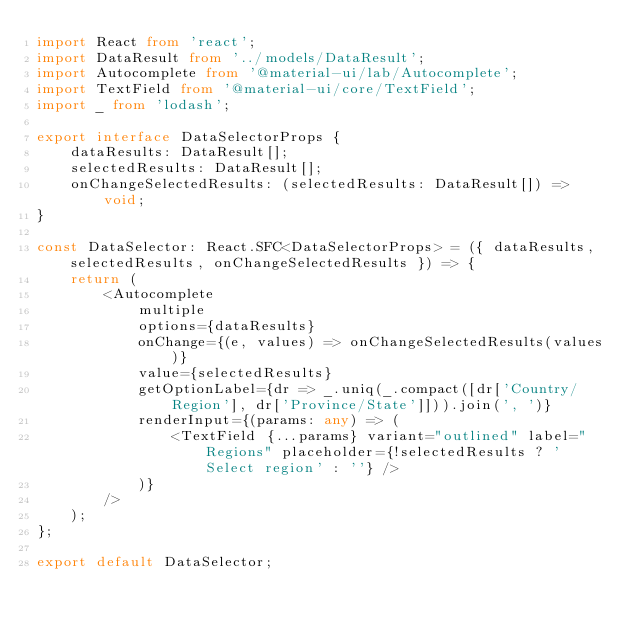Convert code to text. <code><loc_0><loc_0><loc_500><loc_500><_TypeScript_>import React from 'react';
import DataResult from '../models/DataResult';
import Autocomplete from '@material-ui/lab/Autocomplete';
import TextField from '@material-ui/core/TextField';
import _ from 'lodash';

export interface DataSelectorProps {
    dataResults: DataResult[];
    selectedResults: DataResult[];
    onChangeSelectedResults: (selectedResults: DataResult[]) => void;
}

const DataSelector: React.SFC<DataSelectorProps> = ({ dataResults, selectedResults, onChangeSelectedResults }) => {
    return (
        <Autocomplete
            multiple
            options={dataResults}
            onChange={(e, values) => onChangeSelectedResults(values)}
            value={selectedResults}
            getOptionLabel={dr => _.uniq(_.compact([dr['Country/Region'], dr['Province/State']])).join(', ')}
            renderInput={(params: any) => (
                <TextField {...params} variant="outlined" label="Regions" placeholder={!selectedResults ? 'Select region' : ''} />
            )}
        />
    );
};

export default DataSelector;
</code> 